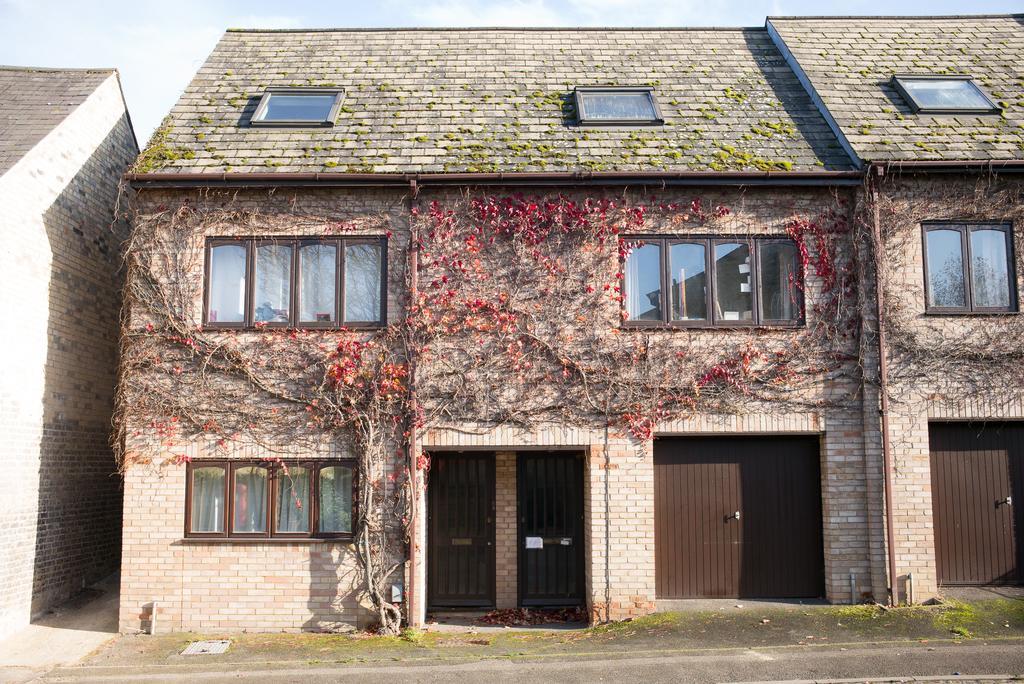Please provide a concise description of this image. In this image I can see the road. I can see a tree. I can see the houses with the windows and doors. At the top I can see the clouds in the sky. 